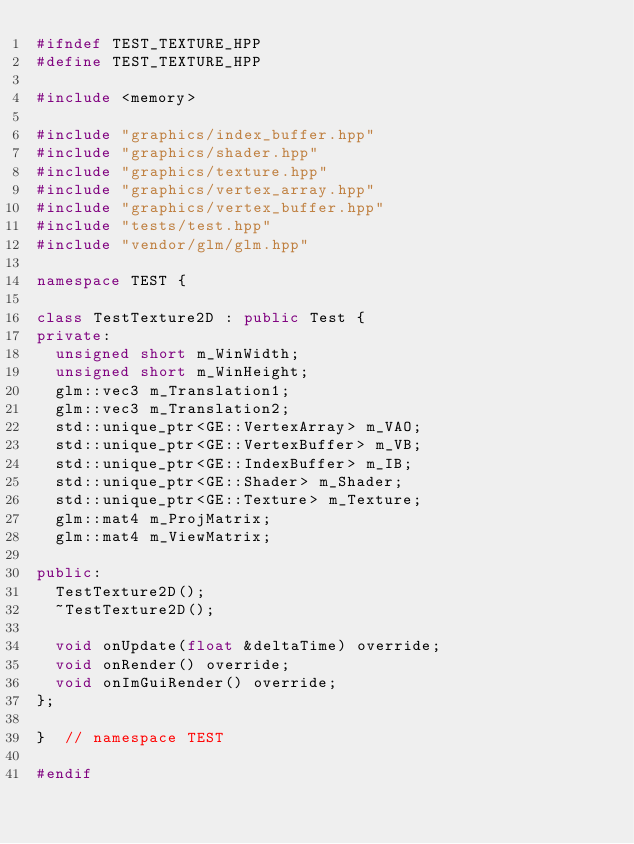<code> <loc_0><loc_0><loc_500><loc_500><_C++_>#ifndef TEST_TEXTURE_HPP
#define TEST_TEXTURE_HPP

#include <memory>

#include "graphics/index_buffer.hpp"
#include "graphics/shader.hpp"
#include "graphics/texture.hpp"
#include "graphics/vertex_array.hpp"
#include "graphics/vertex_buffer.hpp"
#include "tests/test.hpp"
#include "vendor/glm/glm.hpp"

namespace TEST {

class TestTexture2D : public Test {
private:
  unsigned short m_WinWidth;
  unsigned short m_WinHeight;
  glm::vec3 m_Translation1;
  glm::vec3 m_Translation2;
  std::unique_ptr<GE::VertexArray> m_VAO;
  std::unique_ptr<GE::VertexBuffer> m_VB;
  std::unique_ptr<GE::IndexBuffer> m_IB;
  std::unique_ptr<GE::Shader> m_Shader;
  std::unique_ptr<GE::Texture> m_Texture;
  glm::mat4 m_ProjMatrix;
  glm::mat4 m_ViewMatrix;

public:
  TestTexture2D();
  ~TestTexture2D();

  void onUpdate(float &deltaTime) override;
  void onRender() override;
  void onImGuiRender() override;
};

}  // namespace TEST

#endif</code> 